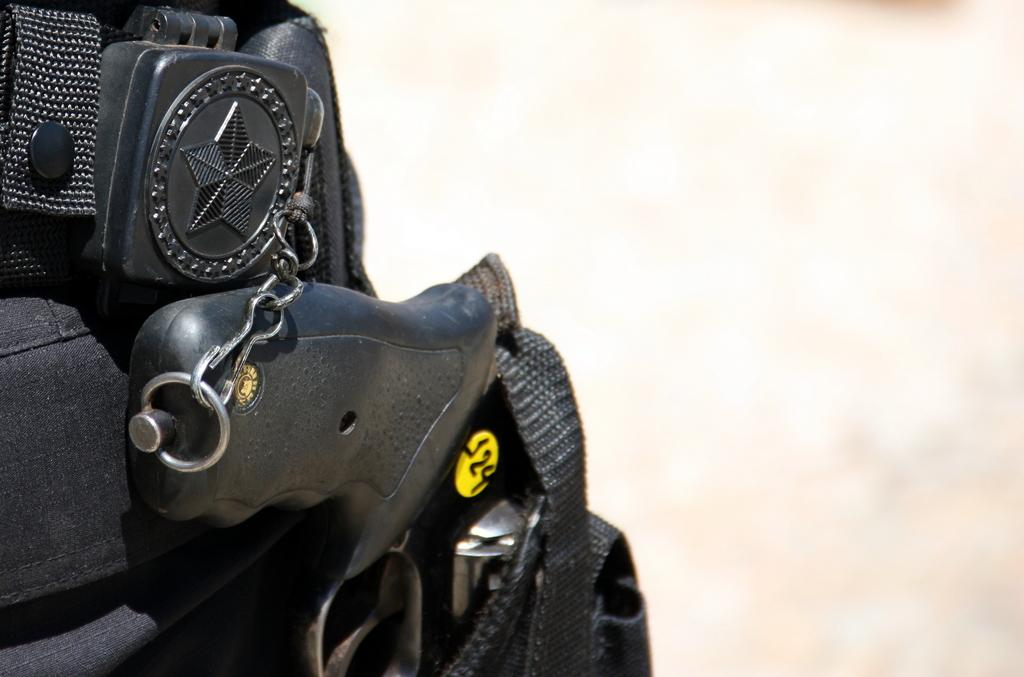What is the color of the object in the image? The object in the image is black. Can you describe the background of the image? The background of the image is blurred. What form of teaching is being demonstrated in the image? There is no teaching activity present in the image; it only features a black object with a blurred background. 